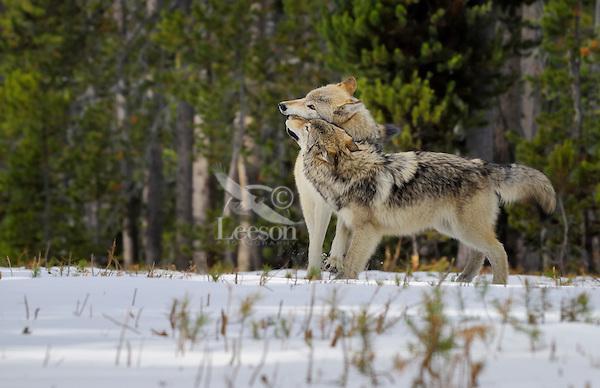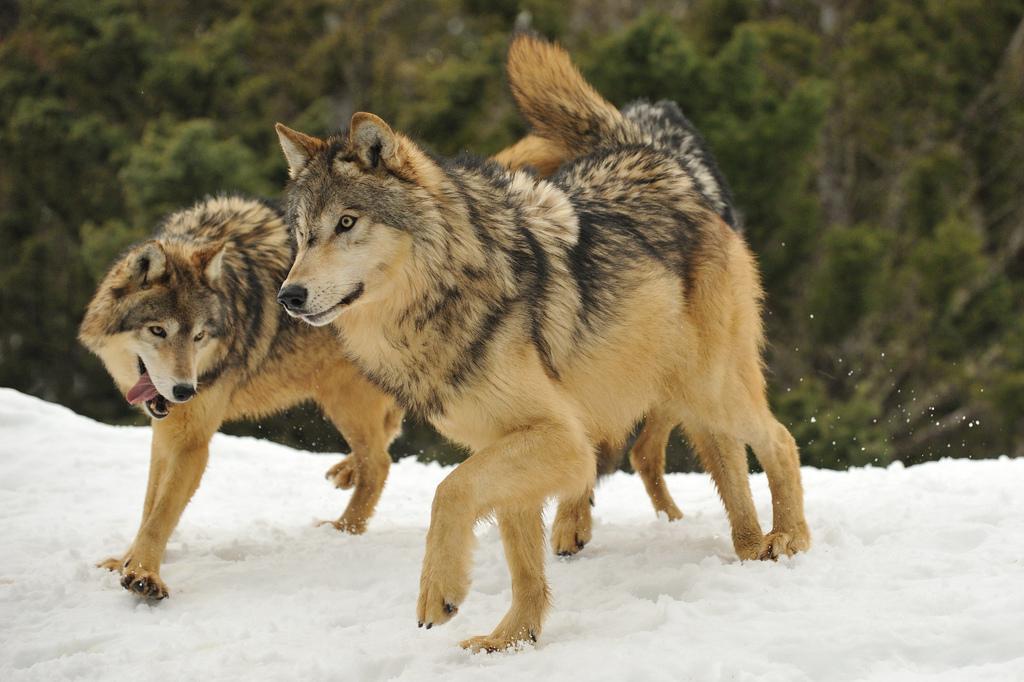The first image is the image on the left, the second image is the image on the right. Evaluate the accuracy of this statement regarding the images: "The right image contains exactly two wolves.". Is it true? Answer yes or no. Yes. The first image is the image on the left, the second image is the image on the right. Assess this claim about the two images: "In each image, multiple wolves interact playfully on a snowy field in front of evergreens.". Correct or not? Answer yes or no. Yes. 